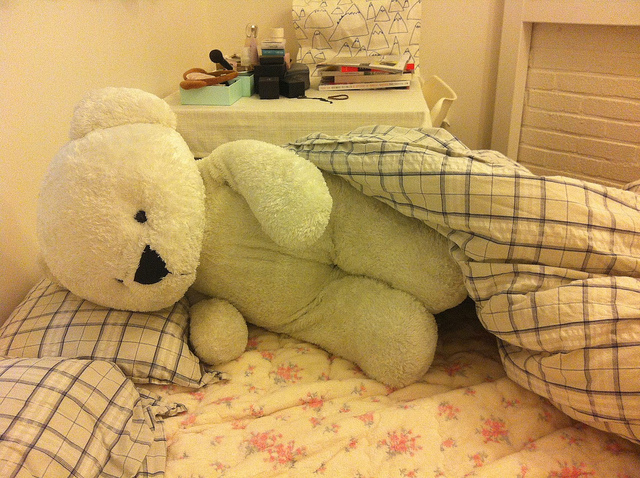<image>Is this a girl or boy's room? I'm not sure if this is a girl's or a boy's room. It could potentially belong to either. Is this a girl or boy's room? I don't know if this is a girl or boy's room. It can be both. 